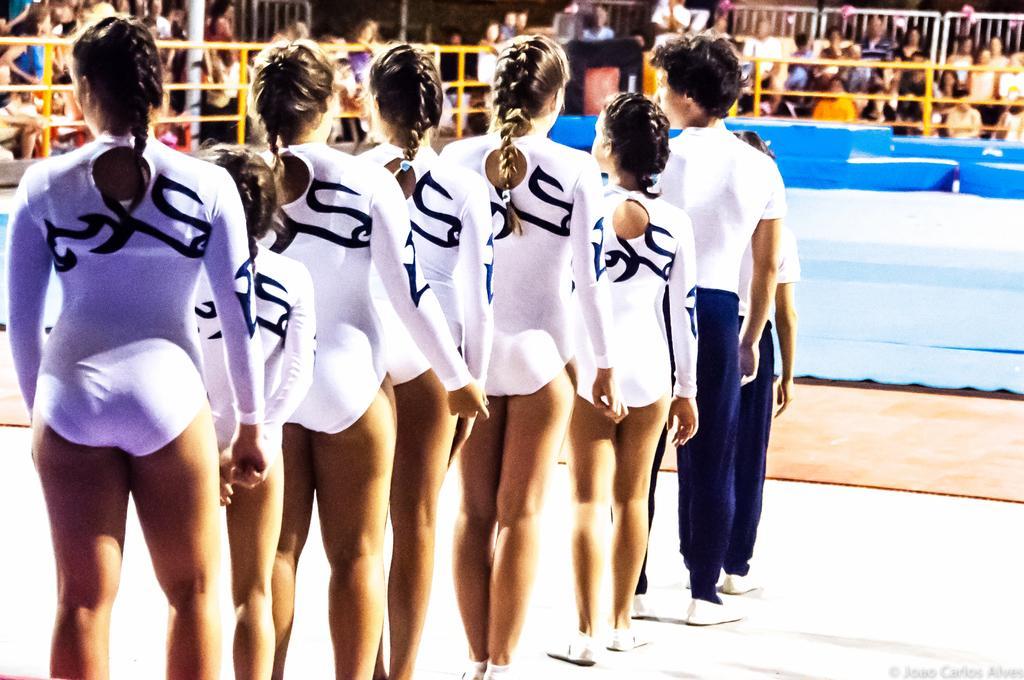In one or two sentences, can you explain what this image depicts? In this image I can see few people are standing and I can see all of them are wearing white colour dress. In the background I can see yellow colour railings and few more people. 